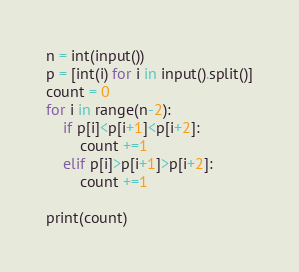<code> <loc_0><loc_0><loc_500><loc_500><_Python_>n = int(input())
p = [int(i) for i in input().split()]
count = 0
for i in range(n-2):
    if p[i]<p[i+1]<p[i+2]:
        count +=1
    elif p[i]>p[i+1]>p[i+2]:
        count +=1

print(count)</code> 